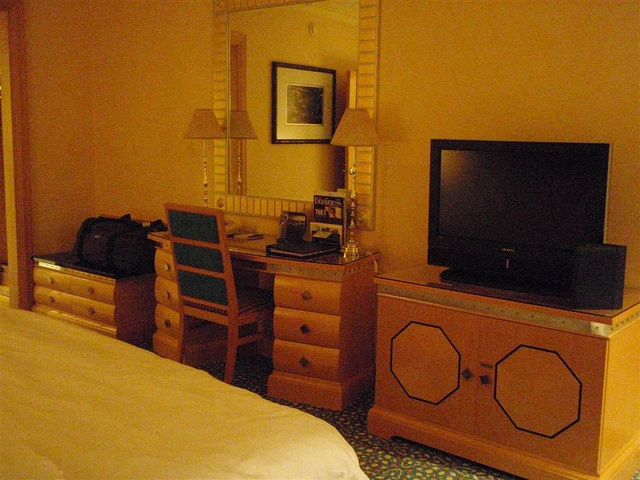Describe the objects in this image and their specific colors. I can see bed in maroon, orange, olive, and tan tones, tv in maroon, black, and brown tones, chair in maroon, black, and brown tones, book in maroon, black, and olive tones, and book in maroon, black, and brown tones in this image. 